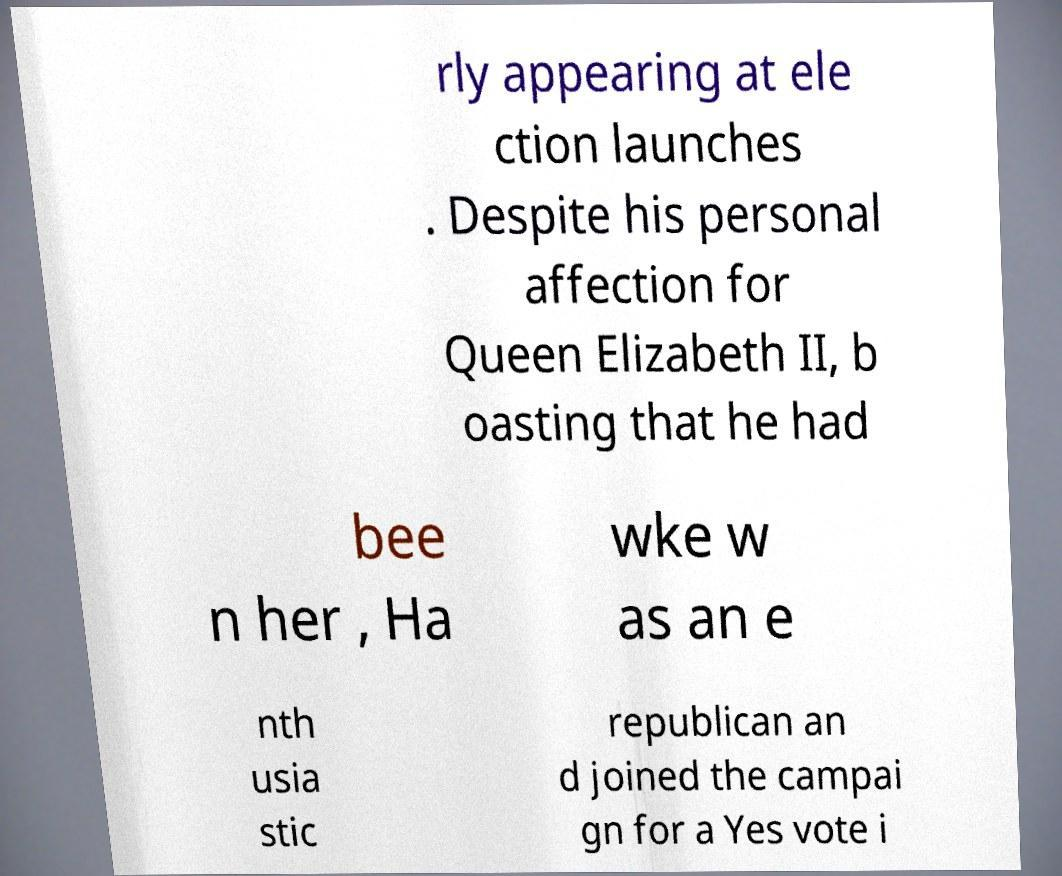Can you read and provide the text displayed in the image?This photo seems to have some interesting text. Can you extract and type it out for me? rly appearing at ele ction launches . Despite his personal affection for Queen Elizabeth II, b oasting that he had bee n her , Ha wke w as an e nth usia stic republican an d joined the campai gn for a Yes vote i 